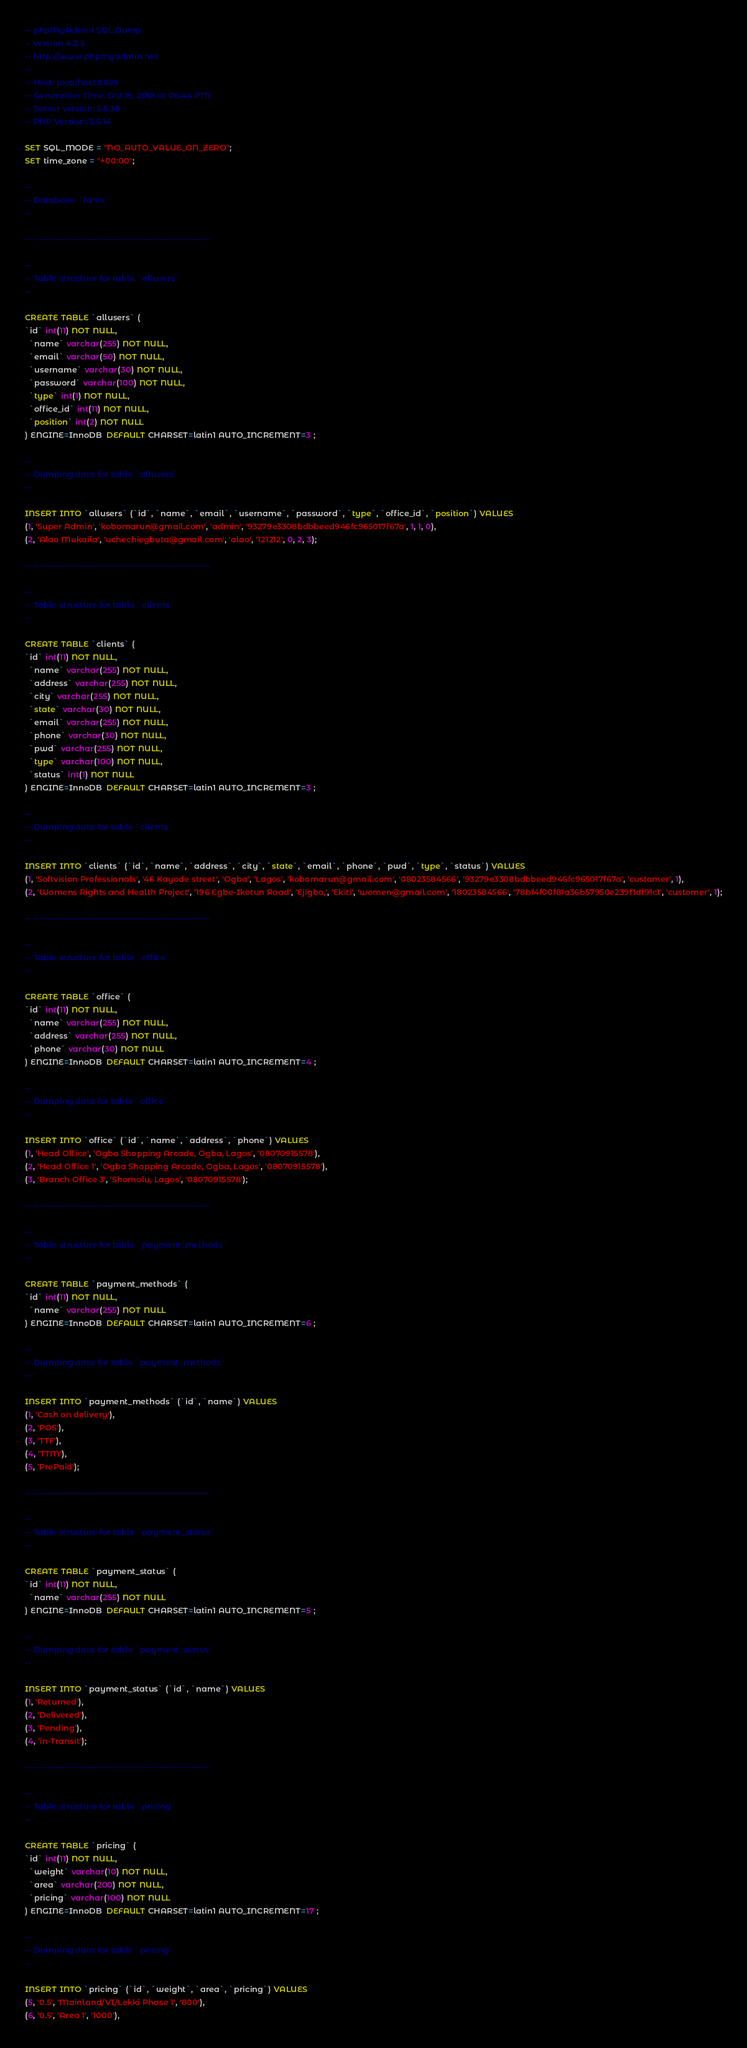Convert code to text. <code><loc_0><loc_0><loc_500><loc_500><_SQL_>-- phpMyAdmin SQL Dump
-- version 4.2.5
-- http://www.phpmyadmin.net
--
-- Host: localhost:8889
-- Generation Time: Oct 19, 2018 at 06:44 PM
-- Server version: 5.5.38
-- PHP Version: 5.5.14

SET SQL_MODE = "NO_AUTO_VALUE_ON_ZERO";
SET time_zone = "+00:00";

--
-- Database: `farex`
--

-- --------------------------------------------------------

--
-- Table structure for table `allusers`
--

CREATE TABLE `allusers` (
`id` int(11) NOT NULL,
  `name` varchar(255) NOT NULL,
  `email` varchar(50) NOT NULL,
  `username` varchar(30) NOT NULL,
  `password` varchar(100) NOT NULL,
  `type` int(1) NOT NULL,
  `office_id` int(11) NOT NULL,
  `position` int(2) NOT NULL
) ENGINE=InnoDB  DEFAULT CHARSET=latin1 AUTO_INCREMENT=3 ;

--
-- Dumping data for table `allusers`
--

INSERT INTO `allusers` (`id`, `name`, `email`, `username`, `password`, `type`, `office_id`, `position`) VALUES
(1, 'Super Admin', 'kobomarun@gmail.com', 'admin', '93279e3308bdbbeed946fc965017f67a', 1, 1, 0),
(2, 'Alao Mukaila', 'uchechiegbuta@gmail.com', 'alao', '121212', 0, 2, 3);

-- --------------------------------------------------------

--
-- Table structure for table `clients`
--

CREATE TABLE `clients` (
`id` int(11) NOT NULL,
  `name` varchar(255) NOT NULL,
  `address` varchar(255) NOT NULL,
  `city` varchar(255) NOT NULL,
  `state` varchar(30) NOT NULL,
  `email` varchar(255) NOT NULL,
  `phone` varchar(30) NOT NULL,
  `pwd` varchar(255) NOT NULL,
  `type` varchar(100) NOT NULL,
  `status` int(1) NOT NULL
) ENGINE=InnoDB  DEFAULT CHARSET=latin1 AUTO_INCREMENT=3 ;

--
-- Dumping data for table `clients`
--

INSERT INTO `clients` (`id`, `name`, `address`, `city`, `state`, `email`, `phone`, `pwd`, `type`, `status`) VALUES
(1, 'Softvision Professionals', '46 Kayode street', 'Ogba', 'Lagos', 'kobomarun@gmail.com', '08023584566', '93279e3308bdbbeed946fc965017f67a', 'customer', 1),
(2, 'Womens Rights and Health Project', '196 Egbe-Ikotun Road', 'Ejigbo,', 'Ekiti', 'women@gmail.com', '18023584566', '78bf4f00f81a36b57950e239f1df91c1', 'customer', 1);

-- --------------------------------------------------------

--
-- Table structure for table `office`
--

CREATE TABLE `office` (
`id` int(11) NOT NULL,
  `name` varchar(255) NOT NULL,
  `address` varchar(255) NOT NULL,
  `phone` varchar(30) NOT NULL
) ENGINE=InnoDB  DEFAULT CHARSET=latin1 AUTO_INCREMENT=4 ;

--
-- Dumping data for table `office`
--

INSERT INTO `office` (`id`, `name`, `address`, `phone`) VALUES
(1, 'Head Office', 'Ogba Shopping Arcade, Ogba, Lagos', '08070915578'),
(2, 'Head Office 1', 'Ogba Shopping Arcade, Ogba, Lagos', '08070915578'),
(3, 'Branch Office 3', 'Shomolu, Lagos', '08070915578');

-- --------------------------------------------------------

--
-- Table structure for table `payment_methods`
--

CREATE TABLE `payment_methods` (
`id` int(11) NOT NULL,
  `name` varchar(255) NOT NULL
) ENGINE=InnoDB  DEFAULT CHARSET=latin1 AUTO_INCREMENT=6 ;

--
-- Dumping data for table `payment_methods`
--

INSERT INTO `payment_methods` (`id`, `name`) VALUES
(1, 'Cash on delivery'),
(2, 'POS'),
(3, 'TTF'),
(4, 'TTM'),
(5, 'PrePaid');

-- --------------------------------------------------------

--
-- Table structure for table `payment_status`
--

CREATE TABLE `payment_status` (
`id` int(11) NOT NULL,
  `name` varchar(255) NOT NULL
) ENGINE=InnoDB  DEFAULT CHARSET=latin1 AUTO_INCREMENT=5 ;

--
-- Dumping data for table `payment_status`
--

INSERT INTO `payment_status` (`id`, `name`) VALUES
(1, 'Returned'),
(2, 'Delivered'),
(3, 'Pending'),
(4, 'in-Transit');

-- --------------------------------------------------------

--
-- Table structure for table `pricing`
--

CREATE TABLE `pricing` (
`id` int(11) NOT NULL,
  `weight` varchar(10) NOT NULL,
  `area` varchar(200) NOT NULL,
  `pricing` varchar(100) NOT NULL
) ENGINE=InnoDB  DEFAULT CHARSET=latin1 AUTO_INCREMENT=17 ;

--
-- Dumping data for table `pricing`
--

INSERT INTO `pricing` (`id`, `weight`, `area`, `pricing`) VALUES
(5, '0.5', 'Mainland/VI/Lekki Phase 1', '800'),
(6, '0.5', 'Area 1', '1000'),</code> 